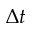<formula> <loc_0><loc_0><loc_500><loc_500>\Delta t</formula> 